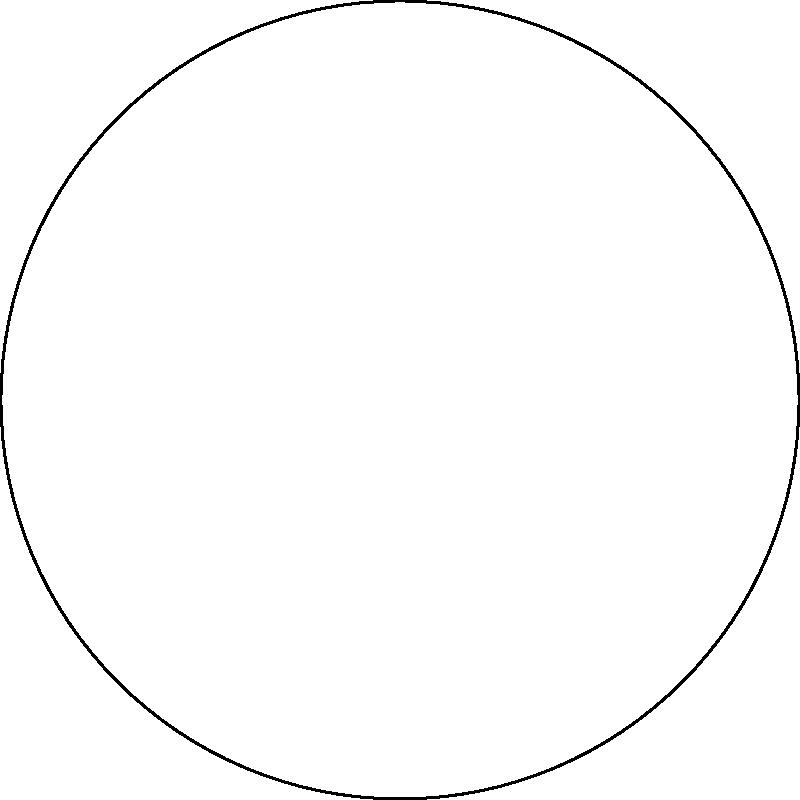In the context of non-Euclidean geometry, consider a triangle drawn on the surface of a sphere, as shown in the diagram. How does the sum of the interior angles of this spherical triangle compare to that of a Euclidean triangle, and what implications does this have for our understanding of space and geometry? To understand the sum of angles in a spherical triangle:

1. Recall that in Euclidean geometry, the sum of angles in a triangle is always 180°.

2. On a sphere, straight lines are represented by great circles (the largest circles that can be drawn on the sphere's surface).

3. In spherical geometry, the sum of angles in a triangle is always greater than 180°. This is due to the positive curvature of the sphere's surface.

4. The formula for the sum of angles in a spherical triangle is:

   $$A + B + C = 180° + \frac{a}{R^2}$$

   Where $A$, $B$, and $C$ are the angles, $a$ is the area of the triangle, and $R$ is the radius of the sphere.

5. This excess over 180° is directly proportional to the area of the triangle on the sphere's surface.

6. As the size of the triangle decreases relative to the sphere's surface, the sum of angles approaches 180°, aligning with Euclidean geometry for small areas.

7. This demonstrates that Euclidean geometry is a limiting case of spherical geometry for small regions.

8. From a Marxist perspective, this concept challenges the notion of absolute truths in geometry, showing that our understanding of space is relative to the context (flat vs. curved surfaces).

9. It illustrates how material conditions (in this case, the surface on which geometry is practiced) influence our theoretical understanding, aligning with the Marxist emphasis on material conditions shaping ideas.
Answer: The sum of angles in a spherical triangle is greater than 180°, varying with the triangle's area, which challenges Euclidean assumptions and demonstrates the relativity of geometric truths based on material conditions. 